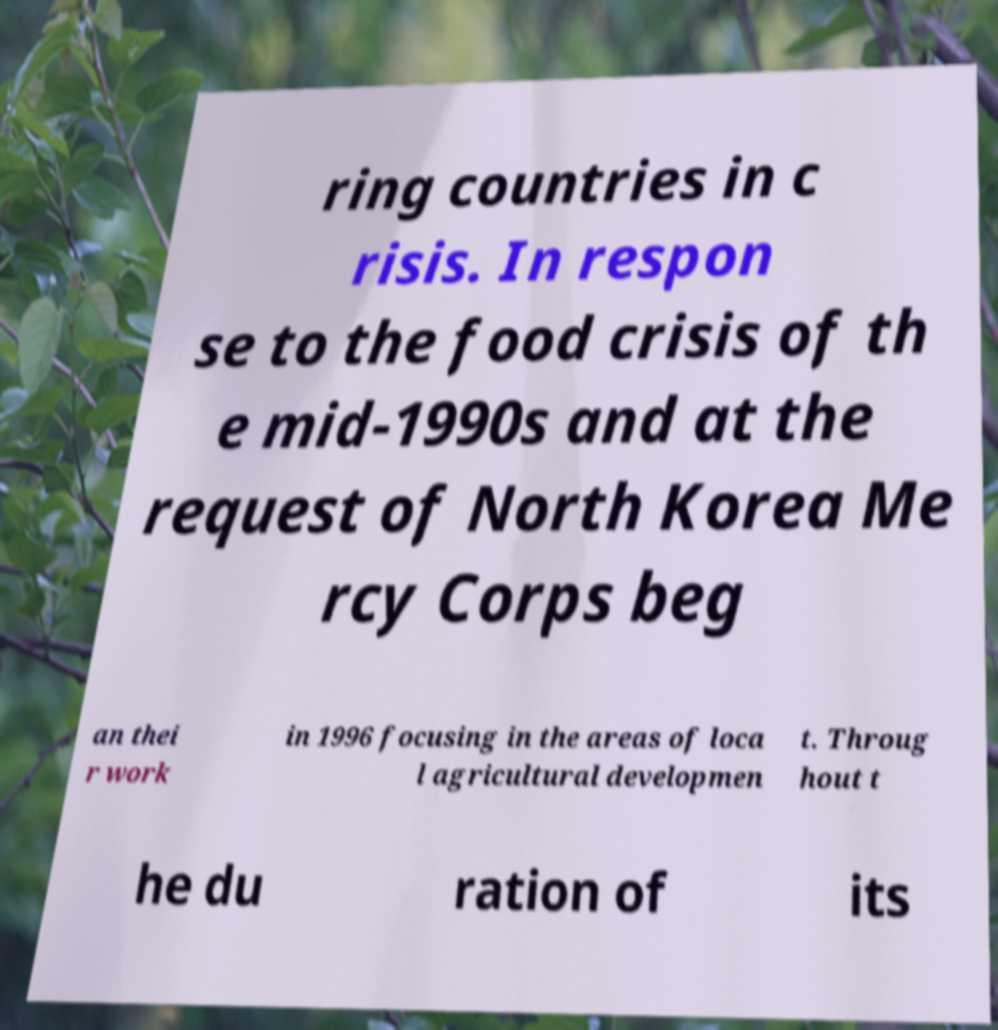Can you read and provide the text displayed in the image?This photo seems to have some interesting text. Can you extract and type it out for me? ring countries in c risis. In respon se to the food crisis of th e mid-1990s and at the request of North Korea Me rcy Corps beg an thei r work in 1996 focusing in the areas of loca l agricultural developmen t. Throug hout t he du ration of its 